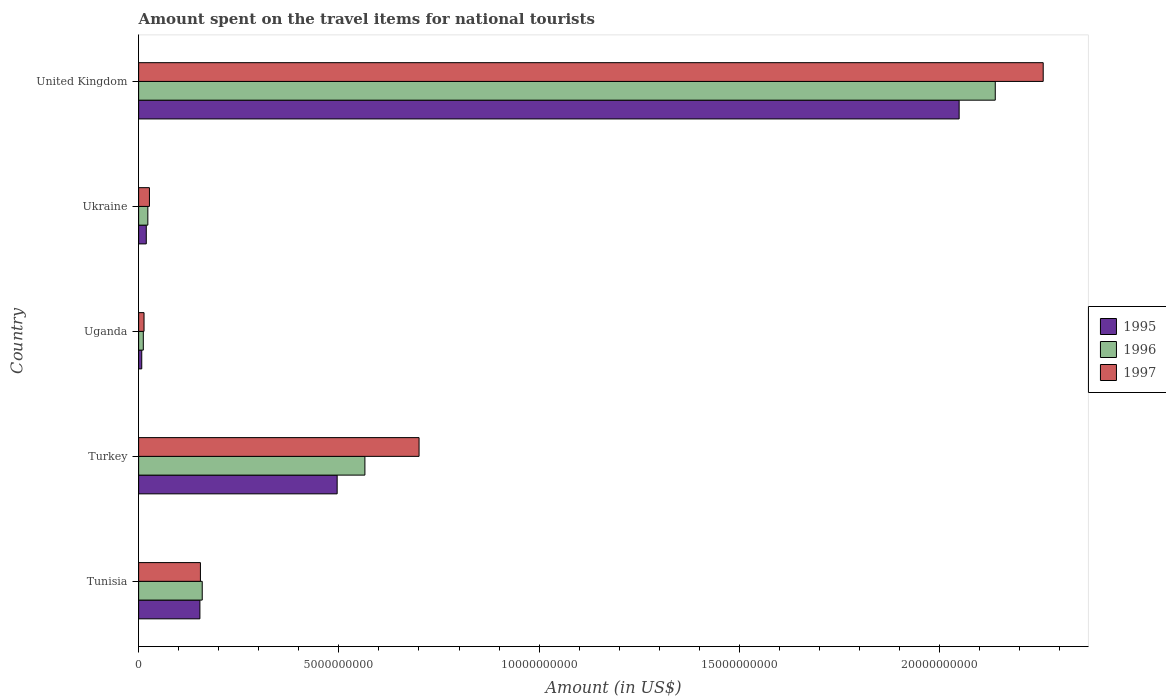Are the number of bars per tick equal to the number of legend labels?
Make the answer very short. Yes. Are the number of bars on each tick of the Y-axis equal?
Keep it short and to the point. Yes. How many bars are there on the 2nd tick from the bottom?
Give a very brief answer. 3. What is the label of the 4th group of bars from the top?
Your answer should be compact. Turkey. In how many cases, is the number of bars for a given country not equal to the number of legend labels?
Provide a short and direct response. 0. What is the amount spent on the travel items for national tourists in 1996 in United Kingdom?
Keep it short and to the point. 2.14e+1. Across all countries, what is the maximum amount spent on the travel items for national tourists in 1995?
Provide a succinct answer. 2.05e+1. Across all countries, what is the minimum amount spent on the travel items for national tourists in 1996?
Give a very brief answer. 1.17e+08. In which country was the amount spent on the travel items for national tourists in 1996 minimum?
Your answer should be very brief. Uganda. What is the total amount spent on the travel items for national tourists in 1997 in the graph?
Ensure brevity in your answer.  3.15e+1. What is the difference between the amount spent on the travel items for national tourists in 1996 in Uganda and that in Ukraine?
Your answer should be compact. -1.13e+08. What is the difference between the amount spent on the travel items for national tourists in 1997 in Uganda and the amount spent on the travel items for national tourists in 1996 in United Kingdom?
Provide a succinct answer. -2.13e+1. What is the average amount spent on the travel items for national tourists in 1997 per country?
Your response must be concise. 6.31e+09. What is the difference between the amount spent on the travel items for national tourists in 1995 and amount spent on the travel items for national tourists in 1996 in Turkey?
Provide a short and direct response. -6.93e+08. In how many countries, is the amount spent on the travel items for national tourists in 1997 greater than 21000000000 US$?
Offer a very short reply. 1. What is the ratio of the amount spent on the travel items for national tourists in 1995 in Turkey to that in Uganda?
Give a very brief answer. 63.55. Is the difference between the amount spent on the travel items for national tourists in 1995 in Tunisia and United Kingdom greater than the difference between the amount spent on the travel items for national tourists in 1996 in Tunisia and United Kingdom?
Ensure brevity in your answer.  Yes. What is the difference between the highest and the second highest amount spent on the travel items for national tourists in 1997?
Offer a terse response. 1.56e+1. What is the difference between the highest and the lowest amount spent on the travel items for national tourists in 1996?
Your response must be concise. 2.13e+1. Is the sum of the amount spent on the travel items for national tourists in 1997 in Ukraine and United Kingdom greater than the maximum amount spent on the travel items for national tourists in 1995 across all countries?
Your response must be concise. Yes. What does the 2nd bar from the top in United Kingdom represents?
Keep it short and to the point. 1996. What does the 3rd bar from the bottom in Tunisia represents?
Offer a very short reply. 1997. Is it the case that in every country, the sum of the amount spent on the travel items for national tourists in 1997 and amount spent on the travel items for national tourists in 1995 is greater than the amount spent on the travel items for national tourists in 1996?
Your answer should be compact. Yes. Are all the bars in the graph horizontal?
Keep it short and to the point. Yes. How many countries are there in the graph?
Keep it short and to the point. 5. What is the difference between two consecutive major ticks on the X-axis?
Make the answer very short. 5.00e+09. Does the graph contain any zero values?
Keep it short and to the point. No. Does the graph contain grids?
Your response must be concise. No. Where does the legend appear in the graph?
Keep it short and to the point. Center right. How many legend labels are there?
Your answer should be very brief. 3. What is the title of the graph?
Give a very brief answer. Amount spent on the travel items for national tourists. Does "2015" appear as one of the legend labels in the graph?
Provide a succinct answer. No. What is the Amount (in US$) of 1995 in Tunisia?
Provide a succinct answer. 1.53e+09. What is the Amount (in US$) in 1996 in Tunisia?
Ensure brevity in your answer.  1.59e+09. What is the Amount (in US$) of 1997 in Tunisia?
Offer a terse response. 1.54e+09. What is the Amount (in US$) of 1995 in Turkey?
Make the answer very short. 4.96e+09. What is the Amount (in US$) in 1996 in Turkey?
Provide a short and direct response. 5.65e+09. What is the Amount (in US$) in 1997 in Turkey?
Provide a succinct answer. 7.00e+09. What is the Amount (in US$) of 1995 in Uganda?
Give a very brief answer. 7.80e+07. What is the Amount (in US$) in 1996 in Uganda?
Your answer should be compact. 1.17e+08. What is the Amount (in US$) of 1997 in Uganda?
Provide a short and direct response. 1.35e+08. What is the Amount (in US$) of 1995 in Ukraine?
Offer a terse response. 1.91e+08. What is the Amount (in US$) of 1996 in Ukraine?
Keep it short and to the point. 2.30e+08. What is the Amount (in US$) of 1997 in Ukraine?
Ensure brevity in your answer.  2.70e+08. What is the Amount (in US$) of 1995 in United Kingdom?
Offer a very short reply. 2.05e+1. What is the Amount (in US$) of 1996 in United Kingdom?
Provide a succinct answer. 2.14e+1. What is the Amount (in US$) in 1997 in United Kingdom?
Your answer should be very brief. 2.26e+1. Across all countries, what is the maximum Amount (in US$) in 1995?
Offer a very short reply. 2.05e+1. Across all countries, what is the maximum Amount (in US$) of 1996?
Your answer should be very brief. 2.14e+1. Across all countries, what is the maximum Amount (in US$) in 1997?
Keep it short and to the point. 2.26e+1. Across all countries, what is the minimum Amount (in US$) of 1995?
Keep it short and to the point. 7.80e+07. Across all countries, what is the minimum Amount (in US$) of 1996?
Give a very brief answer. 1.17e+08. Across all countries, what is the minimum Amount (in US$) in 1997?
Ensure brevity in your answer.  1.35e+08. What is the total Amount (in US$) in 1995 in the graph?
Make the answer very short. 2.72e+1. What is the total Amount (in US$) in 1996 in the graph?
Offer a very short reply. 2.90e+1. What is the total Amount (in US$) in 1997 in the graph?
Offer a terse response. 3.15e+1. What is the difference between the Amount (in US$) in 1995 in Tunisia and that in Turkey?
Keep it short and to the point. -3.43e+09. What is the difference between the Amount (in US$) of 1996 in Tunisia and that in Turkey?
Keep it short and to the point. -4.06e+09. What is the difference between the Amount (in US$) in 1997 in Tunisia and that in Turkey?
Your response must be concise. -5.46e+09. What is the difference between the Amount (in US$) in 1995 in Tunisia and that in Uganda?
Ensure brevity in your answer.  1.45e+09. What is the difference between the Amount (in US$) of 1996 in Tunisia and that in Uganda?
Your answer should be very brief. 1.47e+09. What is the difference between the Amount (in US$) of 1997 in Tunisia and that in Uganda?
Keep it short and to the point. 1.41e+09. What is the difference between the Amount (in US$) in 1995 in Tunisia and that in Ukraine?
Offer a very short reply. 1.34e+09. What is the difference between the Amount (in US$) in 1996 in Tunisia and that in Ukraine?
Provide a succinct answer. 1.36e+09. What is the difference between the Amount (in US$) of 1997 in Tunisia and that in Ukraine?
Your response must be concise. 1.27e+09. What is the difference between the Amount (in US$) in 1995 in Tunisia and that in United Kingdom?
Your answer should be compact. -1.90e+1. What is the difference between the Amount (in US$) in 1996 in Tunisia and that in United Kingdom?
Your answer should be compact. -1.98e+1. What is the difference between the Amount (in US$) of 1997 in Tunisia and that in United Kingdom?
Provide a succinct answer. -2.10e+1. What is the difference between the Amount (in US$) in 1995 in Turkey and that in Uganda?
Your answer should be very brief. 4.88e+09. What is the difference between the Amount (in US$) of 1996 in Turkey and that in Uganda?
Ensure brevity in your answer.  5.53e+09. What is the difference between the Amount (in US$) in 1997 in Turkey and that in Uganda?
Provide a succinct answer. 6.87e+09. What is the difference between the Amount (in US$) of 1995 in Turkey and that in Ukraine?
Make the answer very short. 4.77e+09. What is the difference between the Amount (in US$) in 1996 in Turkey and that in Ukraine?
Offer a very short reply. 5.42e+09. What is the difference between the Amount (in US$) of 1997 in Turkey and that in Ukraine?
Provide a short and direct response. 6.73e+09. What is the difference between the Amount (in US$) of 1995 in Turkey and that in United Kingdom?
Your answer should be very brief. -1.55e+1. What is the difference between the Amount (in US$) in 1996 in Turkey and that in United Kingdom?
Your response must be concise. -1.57e+1. What is the difference between the Amount (in US$) of 1997 in Turkey and that in United Kingdom?
Keep it short and to the point. -1.56e+1. What is the difference between the Amount (in US$) in 1995 in Uganda and that in Ukraine?
Your answer should be compact. -1.13e+08. What is the difference between the Amount (in US$) of 1996 in Uganda and that in Ukraine?
Your answer should be very brief. -1.13e+08. What is the difference between the Amount (in US$) in 1997 in Uganda and that in Ukraine?
Provide a short and direct response. -1.35e+08. What is the difference between the Amount (in US$) of 1995 in Uganda and that in United Kingdom?
Your answer should be compact. -2.04e+1. What is the difference between the Amount (in US$) of 1996 in Uganda and that in United Kingdom?
Your answer should be very brief. -2.13e+1. What is the difference between the Amount (in US$) of 1997 in Uganda and that in United Kingdom?
Offer a very short reply. -2.25e+1. What is the difference between the Amount (in US$) in 1995 in Ukraine and that in United Kingdom?
Your answer should be very brief. -2.03e+1. What is the difference between the Amount (in US$) in 1996 in Ukraine and that in United Kingdom?
Provide a short and direct response. -2.12e+1. What is the difference between the Amount (in US$) of 1997 in Ukraine and that in United Kingdom?
Give a very brief answer. -2.23e+1. What is the difference between the Amount (in US$) of 1995 in Tunisia and the Amount (in US$) of 1996 in Turkey?
Provide a short and direct response. -4.12e+09. What is the difference between the Amount (in US$) of 1995 in Tunisia and the Amount (in US$) of 1997 in Turkey?
Ensure brevity in your answer.  -5.47e+09. What is the difference between the Amount (in US$) of 1996 in Tunisia and the Amount (in US$) of 1997 in Turkey?
Offer a very short reply. -5.41e+09. What is the difference between the Amount (in US$) of 1995 in Tunisia and the Amount (in US$) of 1996 in Uganda?
Give a very brief answer. 1.41e+09. What is the difference between the Amount (in US$) of 1995 in Tunisia and the Amount (in US$) of 1997 in Uganda?
Offer a terse response. 1.40e+09. What is the difference between the Amount (in US$) in 1996 in Tunisia and the Amount (in US$) in 1997 in Uganda?
Keep it short and to the point. 1.45e+09. What is the difference between the Amount (in US$) of 1995 in Tunisia and the Amount (in US$) of 1996 in Ukraine?
Keep it short and to the point. 1.30e+09. What is the difference between the Amount (in US$) of 1995 in Tunisia and the Amount (in US$) of 1997 in Ukraine?
Offer a terse response. 1.26e+09. What is the difference between the Amount (in US$) of 1996 in Tunisia and the Amount (in US$) of 1997 in Ukraine?
Provide a short and direct response. 1.32e+09. What is the difference between the Amount (in US$) in 1995 in Tunisia and the Amount (in US$) in 1996 in United Kingdom?
Provide a short and direct response. -1.99e+1. What is the difference between the Amount (in US$) in 1995 in Tunisia and the Amount (in US$) in 1997 in United Kingdom?
Offer a terse response. -2.11e+1. What is the difference between the Amount (in US$) in 1996 in Tunisia and the Amount (in US$) in 1997 in United Kingdom?
Offer a terse response. -2.10e+1. What is the difference between the Amount (in US$) in 1995 in Turkey and the Amount (in US$) in 1996 in Uganda?
Provide a succinct answer. 4.84e+09. What is the difference between the Amount (in US$) of 1995 in Turkey and the Amount (in US$) of 1997 in Uganda?
Make the answer very short. 4.82e+09. What is the difference between the Amount (in US$) in 1996 in Turkey and the Amount (in US$) in 1997 in Uganda?
Keep it short and to the point. 5.52e+09. What is the difference between the Amount (in US$) in 1995 in Turkey and the Amount (in US$) in 1996 in Ukraine?
Make the answer very short. 4.73e+09. What is the difference between the Amount (in US$) in 1995 in Turkey and the Amount (in US$) in 1997 in Ukraine?
Ensure brevity in your answer.  4.69e+09. What is the difference between the Amount (in US$) in 1996 in Turkey and the Amount (in US$) in 1997 in Ukraine?
Make the answer very short. 5.38e+09. What is the difference between the Amount (in US$) in 1995 in Turkey and the Amount (in US$) in 1996 in United Kingdom?
Offer a very short reply. -1.64e+1. What is the difference between the Amount (in US$) of 1995 in Turkey and the Amount (in US$) of 1997 in United Kingdom?
Your answer should be compact. -1.76e+1. What is the difference between the Amount (in US$) in 1996 in Turkey and the Amount (in US$) in 1997 in United Kingdom?
Keep it short and to the point. -1.69e+1. What is the difference between the Amount (in US$) in 1995 in Uganda and the Amount (in US$) in 1996 in Ukraine?
Offer a terse response. -1.52e+08. What is the difference between the Amount (in US$) in 1995 in Uganda and the Amount (in US$) in 1997 in Ukraine?
Your response must be concise. -1.92e+08. What is the difference between the Amount (in US$) of 1996 in Uganda and the Amount (in US$) of 1997 in Ukraine?
Your answer should be compact. -1.53e+08. What is the difference between the Amount (in US$) in 1995 in Uganda and the Amount (in US$) in 1996 in United Kingdom?
Offer a terse response. -2.13e+1. What is the difference between the Amount (in US$) in 1995 in Uganda and the Amount (in US$) in 1997 in United Kingdom?
Keep it short and to the point. -2.25e+1. What is the difference between the Amount (in US$) of 1996 in Uganda and the Amount (in US$) of 1997 in United Kingdom?
Offer a terse response. -2.25e+1. What is the difference between the Amount (in US$) in 1995 in Ukraine and the Amount (in US$) in 1996 in United Kingdom?
Offer a terse response. -2.12e+1. What is the difference between the Amount (in US$) of 1995 in Ukraine and the Amount (in US$) of 1997 in United Kingdom?
Make the answer very short. -2.24e+1. What is the difference between the Amount (in US$) in 1996 in Ukraine and the Amount (in US$) in 1997 in United Kingdom?
Give a very brief answer. -2.24e+1. What is the average Amount (in US$) of 1995 per country?
Ensure brevity in your answer.  5.45e+09. What is the average Amount (in US$) in 1996 per country?
Provide a short and direct response. 5.79e+09. What is the average Amount (in US$) of 1997 per country?
Your answer should be compact. 6.31e+09. What is the difference between the Amount (in US$) of 1995 and Amount (in US$) of 1996 in Tunisia?
Offer a very short reply. -5.80e+07. What is the difference between the Amount (in US$) in 1995 and Amount (in US$) in 1997 in Tunisia?
Provide a short and direct response. -1.30e+07. What is the difference between the Amount (in US$) of 1996 and Amount (in US$) of 1997 in Tunisia?
Offer a very short reply. 4.50e+07. What is the difference between the Amount (in US$) of 1995 and Amount (in US$) of 1996 in Turkey?
Ensure brevity in your answer.  -6.93e+08. What is the difference between the Amount (in US$) of 1995 and Amount (in US$) of 1997 in Turkey?
Provide a short and direct response. -2.04e+09. What is the difference between the Amount (in US$) in 1996 and Amount (in US$) in 1997 in Turkey?
Provide a short and direct response. -1.35e+09. What is the difference between the Amount (in US$) in 1995 and Amount (in US$) in 1996 in Uganda?
Your response must be concise. -3.90e+07. What is the difference between the Amount (in US$) in 1995 and Amount (in US$) in 1997 in Uganda?
Provide a short and direct response. -5.70e+07. What is the difference between the Amount (in US$) of 1996 and Amount (in US$) of 1997 in Uganda?
Ensure brevity in your answer.  -1.80e+07. What is the difference between the Amount (in US$) of 1995 and Amount (in US$) of 1996 in Ukraine?
Make the answer very short. -3.90e+07. What is the difference between the Amount (in US$) of 1995 and Amount (in US$) of 1997 in Ukraine?
Make the answer very short. -7.90e+07. What is the difference between the Amount (in US$) of 1996 and Amount (in US$) of 1997 in Ukraine?
Ensure brevity in your answer.  -4.00e+07. What is the difference between the Amount (in US$) of 1995 and Amount (in US$) of 1996 in United Kingdom?
Provide a short and direct response. -9.02e+08. What is the difference between the Amount (in US$) of 1995 and Amount (in US$) of 1997 in United Kingdom?
Offer a very short reply. -2.10e+09. What is the difference between the Amount (in US$) of 1996 and Amount (in US$) of 1997 in United Kingdom?
Offer a terse response. -1.20e+09. What is the ratio of the Amount (in US$) of 1995 in Tunisia to that in Turkey?
Your response must be concise. 0.31. What is the ratio of the Amount (in US$) of 1996 in Tunisia to that in Turkey?
Ensure brevity in your answer.  0.28. What is the ratio of the Amount (in US$) in 1997 in Tunisia to that in Turkey?
Your response must be concise. 0.22. What is the ratio of the Amount (in US$) of 1995 in Tunisia to that in Uganda?
Ensure brevity in your answer.  19.62. What is the ratio of the Amount (in US$) in 1996 in Tunisia to that in Uganda?
Provide a short and direct response. 13.57. What is the ratio of the Amount (in US$) in 1997 in Tunisia to that in Uganda?
Provide a short and direct response. 11.43. What is the ratio of the Amount (in US$) of 1995 in Tunisia to that in Ukraine?
Offer a terse response. 8.01. What is the ratio of the Amount (in US$) of 1996 in Tunisia to that in Ukraine?
Give a very brief answer. 6.9. What is the ratio of the Amount (in US$) of 1997 in Tunisia to that in Ukraine?
Keep it short and to the point. 5.71. What is the ratio of the Amount (in US$) in 1995 in Tunisia to that in United Kingdom?
Your answer should be very brief. 0.07. What is the ratio of the Amount (in US$) of 1996 in Tunisia to that in United Kingdom?
Offer a very short reply. 0.07. What is the ratio of the Amount (in US$) in 1997 in Tunisia to that in United Kingdom?
Provide a short and direct response. 0.07. What is the ratio of the Amount (in US$) of 1995 in Turkey to that in Uganda?
Keep it short and to the point. 63.55. What is the ratio of the Amount (in US$) of 1996 in Turkey to that in Uganda?
Keep it short and to the point. 48.29. What is the ratio of the Amount (in US$) of 1997 in Turkey to that in Uganda?
Keep it short and to the point. 51.87. What is the ratio of the Amount (in US$) of 1995 in Turkey to that in Ukraine?
Keep it short and to the point. 25.95. What is the ratio of the Amount (in US$) of 1996 in Turkey to that in Ukraine?
Offer a very short reply. 24.57. What is the ratio of the Amount (in US$) in 1997 in Turkey to that in Ukraine?
Offer a terse response. 25.93. What is the ratio of the Amount (in US$) of 1995 in Turkey to that in United Kingdom?
Offer a terse response. 0.24. What is the ratio of the Amount (in US$) of 1996 in Turkey to that in United Kingdom?
Keep it short and to the point. 0.26. What is the ratio of the Amount (in US$) of 1997 in Turkey to that in United Kingdom?
Provide a succinct answer. 0.31. What is the ratio of the Amount (in US$) in 1995 in Uganda to that in Ukraine?
Your answer should be compact. 0.41. What is the ratio of the Amount (in US$) of 1996 in Uganda to that in Ukraine?
Provide a short and direct response. 0.51. What is the ratio of the Amount (in US$) of 1997 in Uganda to that in Ukraine?
Ensure brevity in your answer.  0.5. What is the ratio of the Amount (in US$) in 1995 in Uganda to that in United Kingdom?
Provide a succinct answer. 0. What is the ratio of the Amount (in US$) of 1996 in Uganda to that in United Kingdom?
Offer a very short reply. 0.01. What is the ratio of the Amount (in US$) in 1997 in Uganda to that in United Kingdom?
Give a very brief answer. 0.01. What is the ratio of the Amount (in US$) in 1995 in Ukraine to that in United Kingdom?
Offer a very short reply. 0.01. What is the ratio of the Amount (in US$) of 1996 in Ukraine to that in United Kingdom?
Offer a terse response. 0.01. What is the ratio of the Amount (in US$) in 1997 in Ukraine to that in United Kingdom?
Make the answer very short. 0.01. What is the difference between the highest and the second highest Amount (in US$) of 1995?
Ensure brevity in your answer.  1.55e+1. What is the difference between the highest and the second highest Amount (in US$) of 1996?
Offer a terse response. 1.57e+1. What is the difference between the highest and the second highest Amount (in US$) of 1997?
Offer a terse response. 1.56e+1. What is the difference between the highest and the lowest Amount (in US$) in 1995?
Your answer should be very brief. 2.04e+1. What is the difference between the highest and the lowest Amount (in US$) in 1996?
Make the answer very short. 2.13e+1. What is the difference between the highest and the lowest Amount (in US$) in 1997?
Your response must be concise. 2.25e+1. 